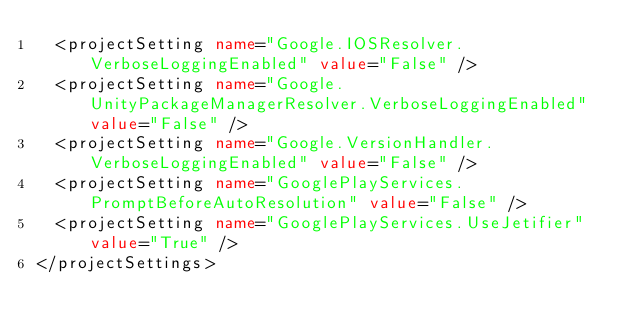<code> <loc_0><loc_0><loc_500><loc_500><_XML_>  <projectSetting name="Google.IOSResolver.VerboseLoggingEnabled" value="False" />
  <projectSetting name="Google.UnityPackageManagerResolver.VerboseLoggingEnabled" value="False" />
  <projectSetting name="Google.VersionHandler.VerboseLoggingEnabled" value="False" />
  <projectSetting name="GooglePlayServices.PromptBeforeAutoResolution" value="False" />
  <projectSetting name="GooglePlayServices.UseJetifier" value="True" />
</projectSettings></code> 